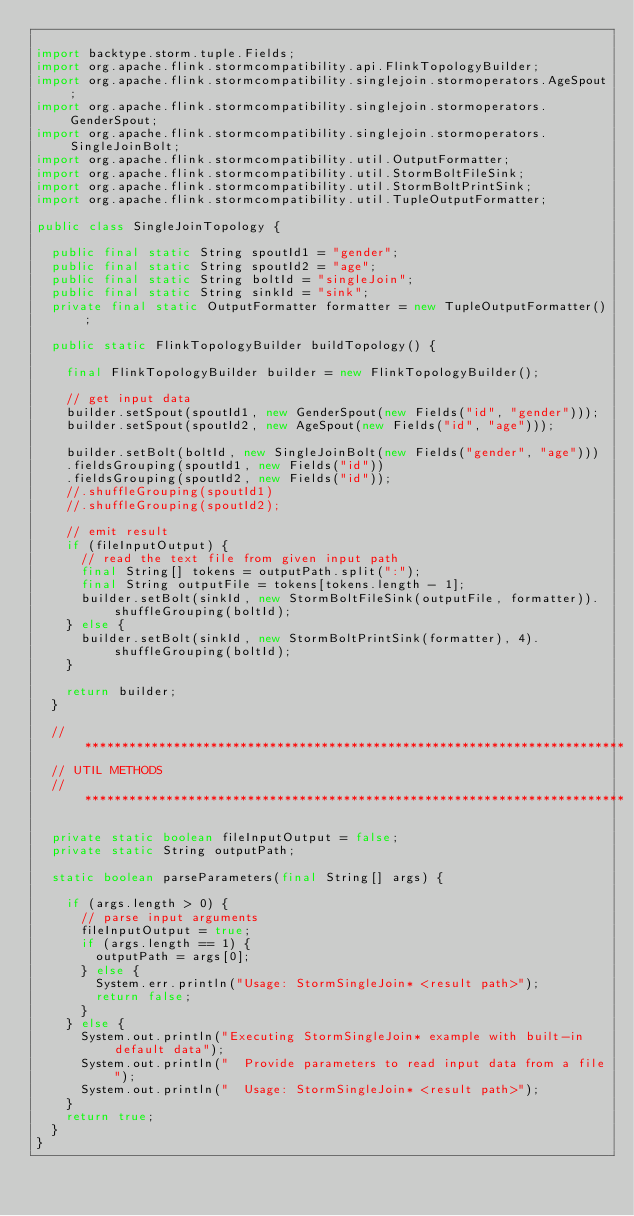<code> <loc_0><loc_0><loc_500><loc_500><_Java_>
import backtype.storm.tuple.Fields;
import org.apache.flink.stormcompatibility.api.FlinkTopologyBuilder;
import org.apache.flink.stormcompatibility.singlejoin.stormoperators.AgeSpout;
import org.apache.flink.stormcompatibility.singlejoin.stormoperators.GenderSpout;
import org.apache.flink.stormcompatibility.singlejoin.stormoperators.SingleJoinBolt;
import org.apache.flink.stormcompatibility.util.OutputFormatter;
import org.apache.flink.stormcompatibility.util.StormBoltFileSink;
import org.apache.flink.stormcompatibility.util.StormBoltPrintSink;
import org.apache.flink.stormcompatibility.util.TupleOutputFormatter;

public class SingleJoinTopology {

	public final static String spoutId1 = "gender";
	public final static String spoutId2 = "age";
	public final static String boltId = "singleJoin";
	public final static String sinkId = "sink";
	private final static OutputFormatter formatter = new TupleOutputFormatter();

	public static FlinkTopologyBuilder buildTopology() {

		final FlinkTopologyBuilder builder = new FlinkTopologyBuilder();

		// get input data
		builder.setSpout(spoutId1, new GenderSpout(new Fields("id", "gender")));
		builder.setSpout(spoutId2, new AgeSpout(new Fields("id", "age")));

		builder.setBolt(boltId, new SingleJoinBolt(new Fields("gender", "age")))
		.fieldsGrouping(spoutId1, new Fields("id"))
		.fieldsGrouping(spoutId2, new Fields("id"));
		//.shuffleGrouping(spoutId1)
		//.shuffleGrouping(spoutId2);

		// emit result
		if (fileInputOutput) {
			// read the text file from given input path
			final String[] tokens = outputPath.split(":");
			final String outputFile = tokens[tokens.length - 1];
			builder.setBolt(sinkId, new StormBoltFileSink(outputFile, formatter)).shuffleGrouping(boltId);
		} else {
			builder.setBolt(sinkId, new StormBoltPrintSink(formatter), 4).shuffleGrouping(boltId);
		}

		return builder;
	}

	// *************************************************************************
	// UTIL METHODS
	// *************************************************************************

	private static boolean fileInputOutput = false;
	private static String outputPath;

	static boolean parseParameters(final String[] args) {

		if (args.length > 0) {
			// parse input arguments
			fileInputOutput = true;
			if (args.length == 1) {
				outputPath = args[0];
			} else {
				System.err.println("Usage: StormSingleJoin* <result path>");
				return false;
			}
		} else {
			System.out.println("Executing StormSingleJoin* example with built-in default data");
			System.out.println("  Provide parameters to read input data from a file");
			System.out.println("  Usage: StormSingleJoin* <result path>");
		}
		return true;
	}
}
</code> 